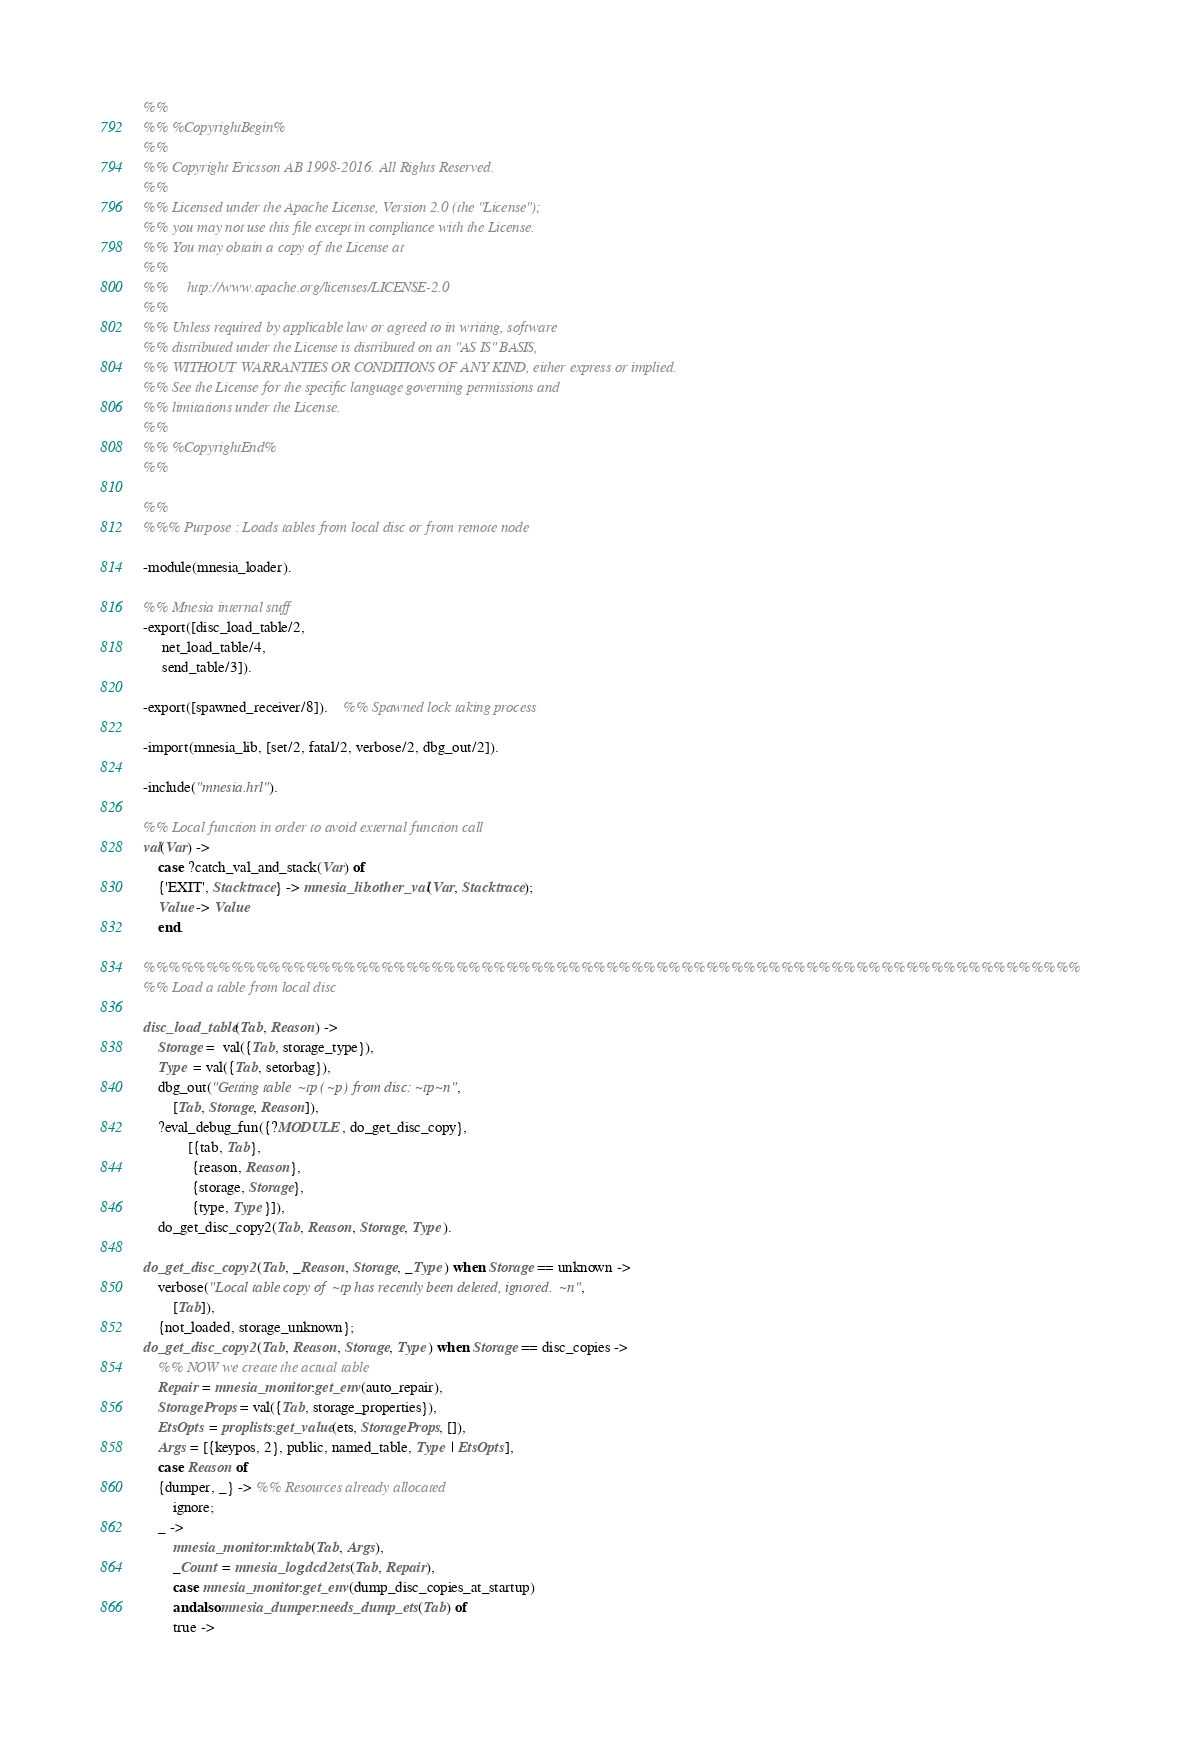<code> <loc_0><loc_0><loc_500><loc_500><_Erlang_>%%
%% %CopyrightBegin%
%%
%% Copyright Ericsson AB 1998-2016. All Rights Reserved.
%%
%% Licensed under the Apache License, Version 2.0 (the "License");
%% you may not use this file except in compliance with the License.
%% You may obtain a copy of the License at
%%
%%     http://www.apache.org/licenses/LICENSE-2.0
%%
%% Unless required by applicable law or agreed to in writing, software
%% distributed under the License is distributed on an "AS IS" BASIS,
%% WITHOUT WARRANTIES OR CONDITIONS OF ANY KIND, either express or implied.
%% See the License for the specific language governing permissions and
%% limitations under the License.
%%
%% %CopyrightEnd%
%%

%%
%%% Purpose : Loads tables from local disc or from remote node

-module(mnesia_loader).

%% Mnesia internal stuff
-export([disc_load_table/2,
	 net_load_table/4,
	 send_table/3]).

-export([spawned_receiver/8]).    %% Spawned lock taking process

-import(mnesia_lib, [set/2, fatal/2, verbose/2, dbg_out/2]).

-include("mnesia.hrl").

%% Local function in order to avoid external function call
val(Var) ->
    case ?catch_val_and_stack(Var) of
	{'EXIT', Stacktrace} -> mnesia_lib:other_val(Var, Stacktrace);
	Value -> Value
    end.

%%%%%%%%%%%%%%%%%%%%%%%%%%%%%%%%%%%%%%%%%%%%%%%%%%%%%%%%%%%%%%%%%%%%%%%%%%%
%% Load a table from local disc

disc_load_table(Tab, Reason) ->
    Storage =  val({Tab, storage_type}),
    Type = val({Tab, setorbag}),
    dbg_out("Getting table ~tp (~p) from disc: ~tp~n",
	    [Tab, Storage, Reason]),
    ?eval_debug_fun({?MODULE, do_get_disc_copy},
		    [{tab, Tab},
		     {reason, Reason},
		     {storage, Storage},
		     {type, Type}]),
    do_get_disc_copy2(Tab, Reason, Storage, Type).

do_get_disc_copy2(Tab, _Reason, Storage, _Type) when Storage == unknown ->
    verbose("Local table copy of ~tp has recently been deleted, ignored.~n",
	    [Tab]),
    {not_loaded, storage_unknown};
do_get_disc_copy2(Tab, Reason, Storage, Type) when Storage == disc_copies ->
    %% NOW we create the actual table
    Repair = mnesia_monitor:get_env(auto_repair),
    StorageProps = val({Tab, storage_properties}),
    EtsOpts = proplists:get_value(ets, StorageProps, []),
    Args = [{keypos, 2}, public, named_table, Type | EtsOpts],
    case Reason of
	{dumper, _} -> %% Resources already allocated
	    ignore;
	_ ->
	    mnesia_monitor:mktab(Tab, Args),
	    _Count = mnesia_log:dcd2ets(Tab, Repair),
	    case mnesia_monitor:get_env(dump_disc_copies_at_startup)
		andalso mnesia_dumper:needs_dump_ets(Tab) of
		true -></code> 